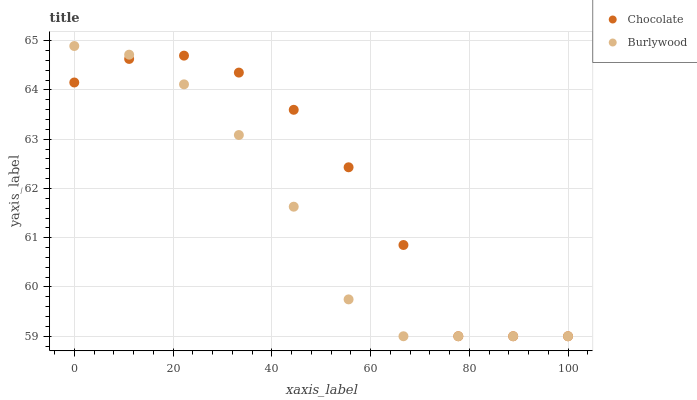Does Burlywood have the minimum area under the curve?
Answer yes or no. Yes. Does Chocolate have the maximum area under the curve?
Answer yes or no. Yes. Does Chocolate have the minimum area under the curve?
Answer yes or no. No. Is Burlywood the smoothest?
Answer yes or no. Yes. Is Chocolate the roughest?
Answer yes or no. Yes. Is Chocolate the smoothest?
Answer yes or no. No. Does Burlywood have the lowest value?
Answer yes or no. Yes. Does Burlywood have the highest value?
Answer yes or no. Yes. Does Chocolate have the highest value?
Answer yes or no. No. Does Burlywood intersect Chocolate?
Answer yes or no. Yes. Is Burlywood less than Chocolate?
Answer yes or no. No. Is Burlywood greater than Chocolate?
Answer yes or no. No. 